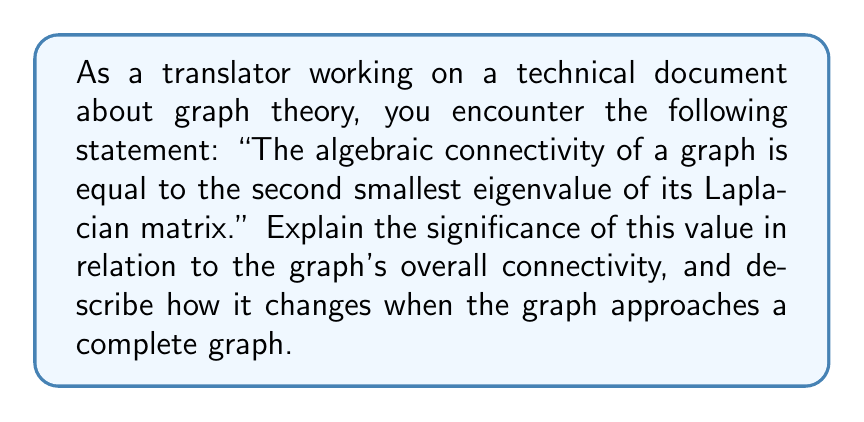Solve this math problem. To understand this concept, let's break it down step-by-step:

1. The Laplacian matrix $L$ of a graph is defined as $L = D - A$, where $D$ is the degree matrix and $A$ is the adjacency matrix.

2. The spectrum of the Laplacian matrix consists of its eigenvalues: $0 = \lambda_1 \leq \lambda_2 \leq ... \leq \lambda_n$.

3. The second smallest eigenvalue $\lambda_2$ is called the algebraic connectivity or Fiedler value.

4. Significance of $\lambda_2$:
   a) $\lambda_2 > 0$ if and only if the graph is connected.
   b) The magnitude of $\lambda_2$ indicates how well-connected the graph is.

5. As the graph approaches a complete graph:
   a) The number of edges increases.
   b) The Laplacian matrix changes: diagonal elements increase, off-diagonal elements become more negative.

6. For a complete graph with $n$ vertices:
   a) The Laplacian spectrum is $\{0, n, n, ..., n\}$.
   b) $\lambda_2 = n$, which is the maximum possible value for a graph with $n$ vertices.

7. Therefore, as a graph becomes more connected and approaches a complete graph:
   a) $\lambda_2$ increases.
   b) The gap between $\lambda_2$ and the higher eigenvalues decreases.

This relationship demonstrates that the algebraic connectivity $\lambda_2$ is a quantitative measure of the graph's overall connectivity, with larger values indicating stronger connectivity.
Answer: The algebraic connectivity $\lambda_2$ increases as the graph becomes more connected, reaching its maximum value of $n$ for a complete graph with $n$ vertices. 